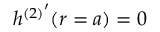<formula> <loc_0><loc_0><loc_500><loc_500>h { ^ { ( 2 ) } } ^ { \prime } ( r = a ) = 0</formula> 